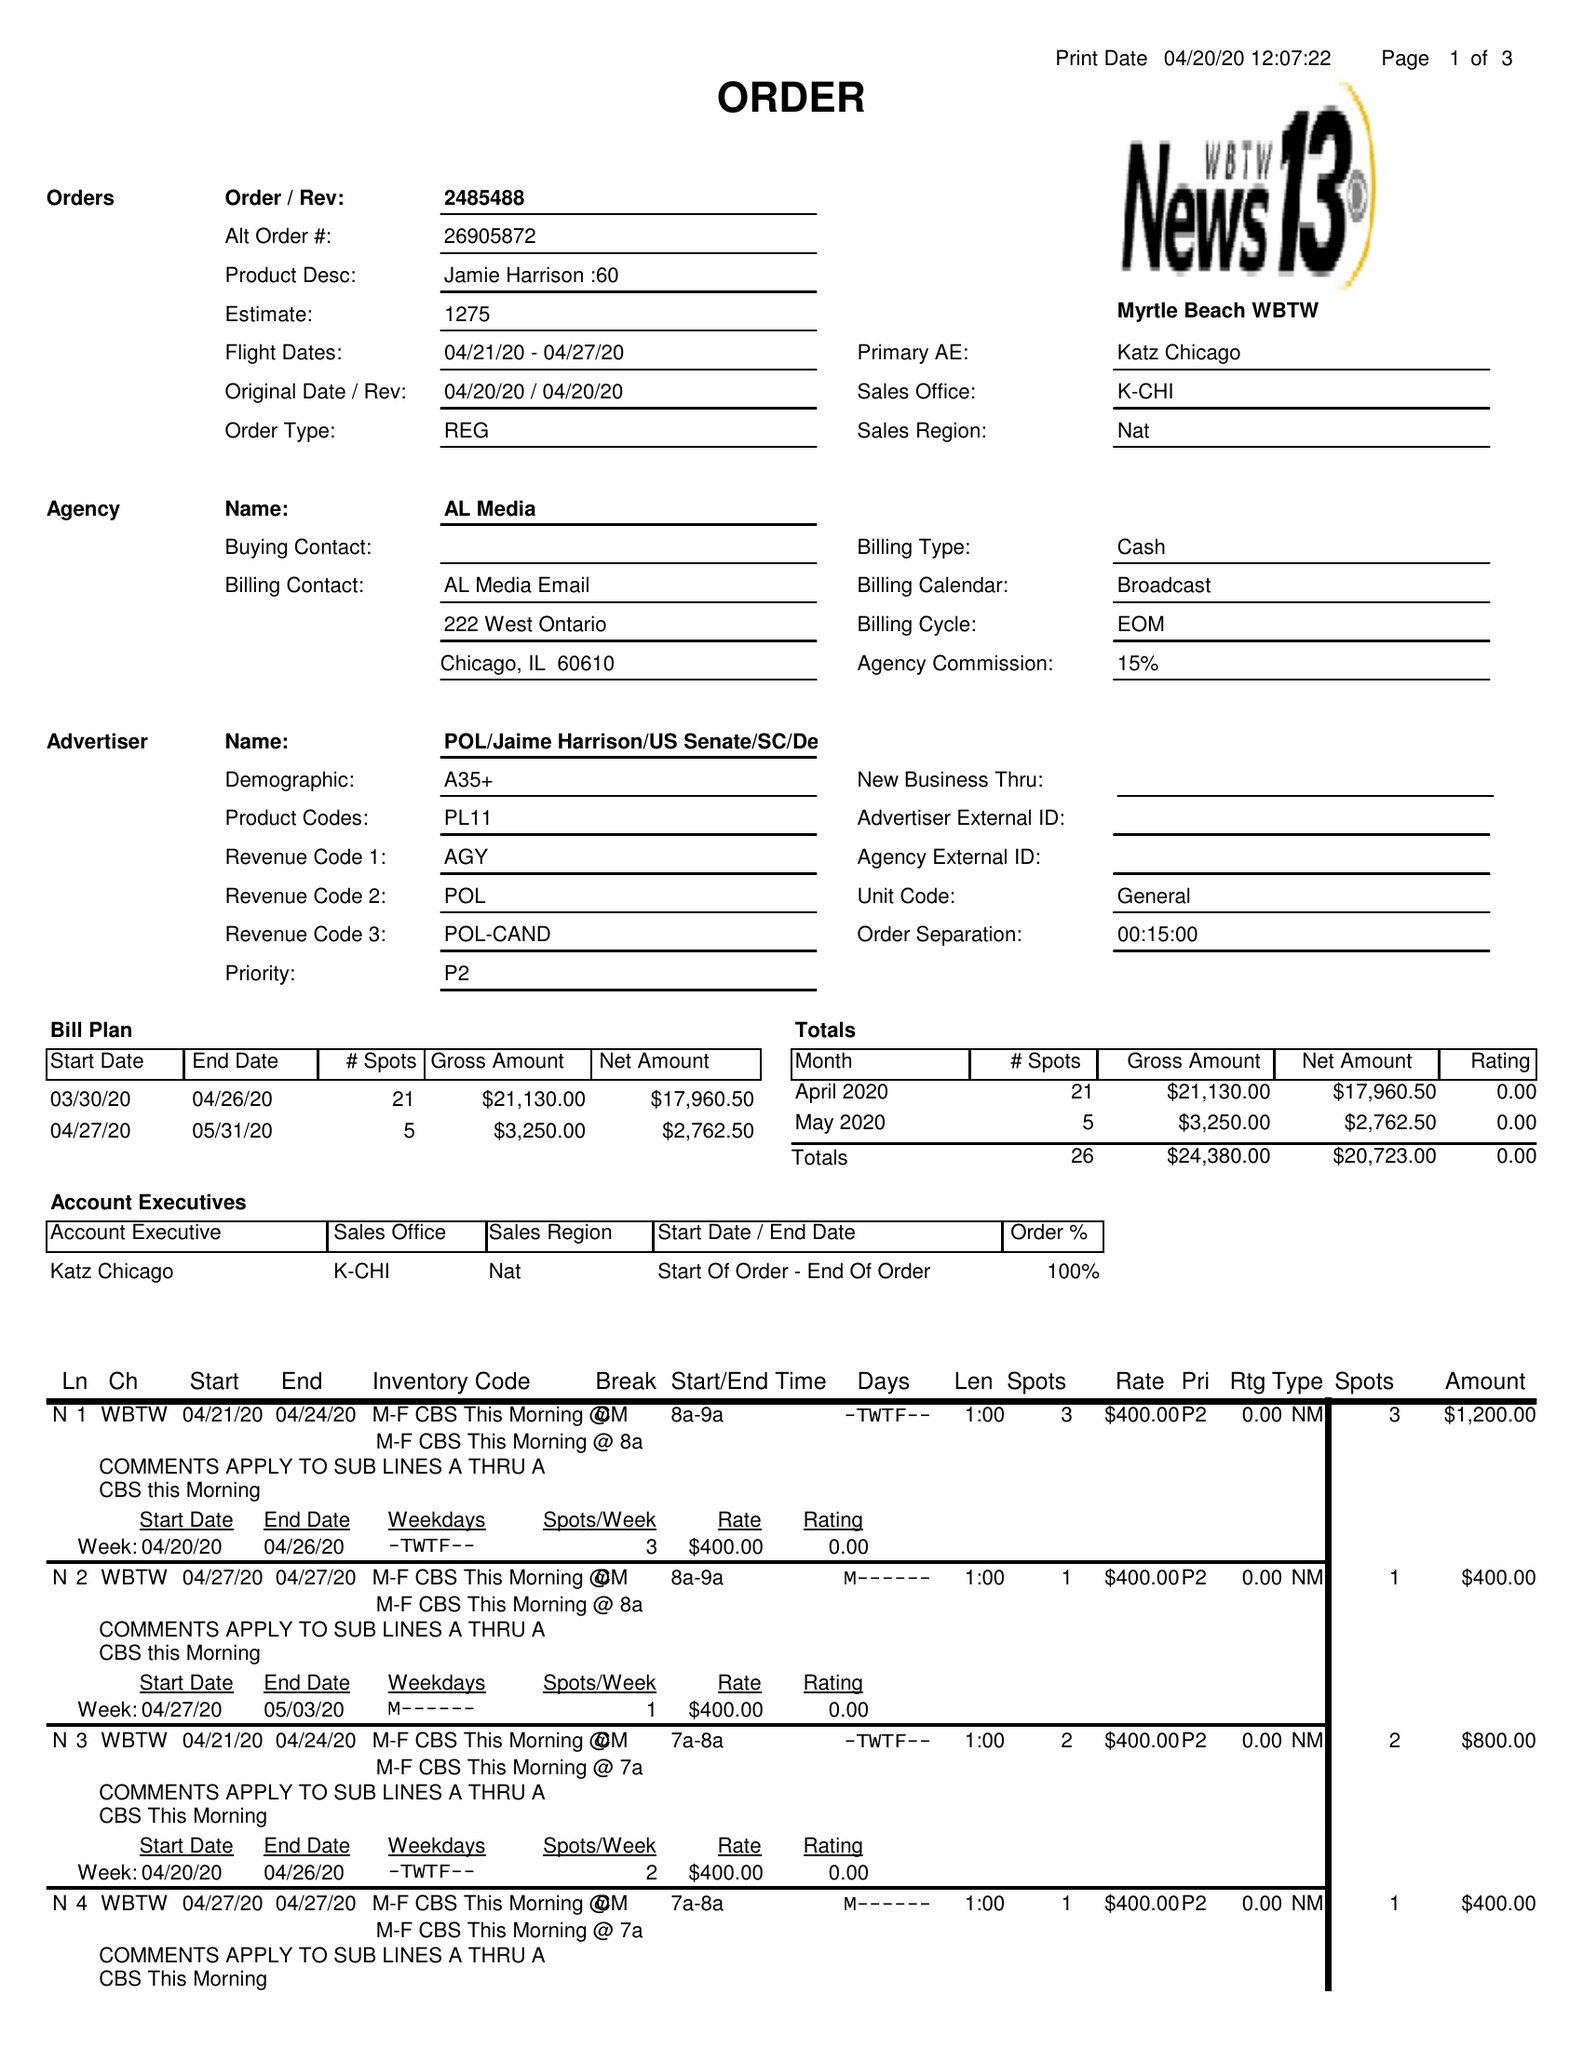What is the value for the advertiser?
Answer the question using a single word or phrase. POL/JAIMEHARRISON/USSENATE/SC/DEM 